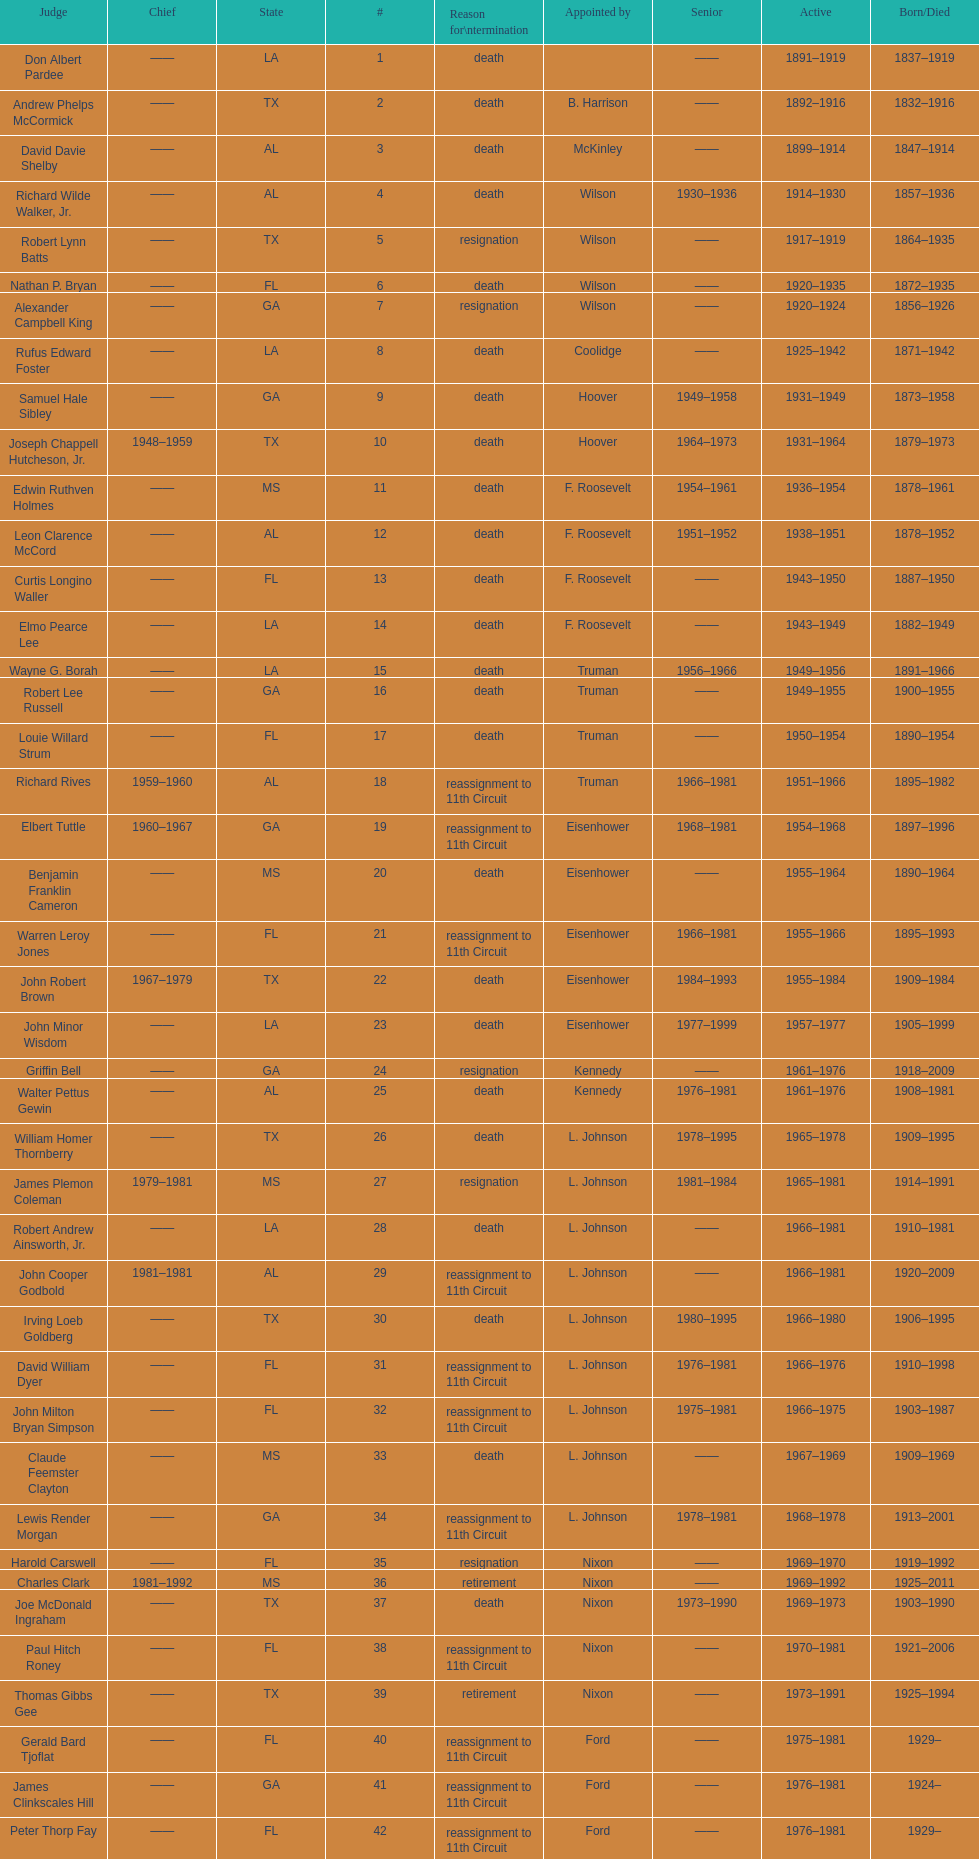Can you parse all the data within this table? {'header': ['Judge', 'Chief', 'State', '#', 'Reason for\\ntermination', 'Appointed by', 'Senior', 'Active', 'Born/Died'], 'rows': [['Don Albert Pardee', '——', 'LA', '1', 'death', '', '——', '1891–1919', '1837–1919'], ['Andrew Phelps McCormick', '——', 'TX', '2', 'death', 'B. Harrison', '——', '1892–1916', '1832–1916'], ['David Davie Shelby', '——', 'AL', '3', 'death', 'McKinley', '——', '1899–1914', '1847–1914'], ['Richard Wilde Walker, Jr.', '——', 'AL', '4', 'death', 'Wilson', '1930–1936', '1914–1930', '1857–1936'], ['Robert Lynn Batts', '——', 'TX', '5', 'resignation', 'Wilson', '——', '1917–1919', '1864–1935'], ['Nathan P. Bryan', '——', 'FL', '6', 'death', 'Wilson', '——', '1920–1935', '1872–1935'], ['Alexander Campbell King', '——', 'GA', '7', 'resignation', 'Wilson', '——', '1920–1924', '1856–1926'], ['Rufus Edward Foster', '——', 'LA', '8', 'death', 'Coolidge', '——', '1925–1942', '1871–1942'], ['Samuel Hale Sibley', '——', 'GA', '9', 'death', 'Hoover', '1949–1958', '1931–1949', '1873–1958'], ['Joseph Chappell Hutcheson, Jr.', '1948–1959', 'TX', '10', 'death', 'Hoover', '1964–1973', '1931–1964', '1879–1973'], ['Edwin Ruthven Holmes', '——', 'MS', '11', 'death', 'F. Roosevelt', '1954–1961', '1936–1954', '1878–1961'], ['Leon Clarence McCord', '——', 'AL', '12', 'death', 'F. Roosevelt', '1951–1952', '1938–1951', '1878–1952'], ['Curtis Longino Waller', '——', 'FL', '13', 'death', 'F. Roosevelt', '——', '1943–1950', '1887–1950'], ['Elmo Pearce Lee', '——', 'LA', '14', 'death', 'F. Roosevelt', '——', '1943–1949', '1882–1949'], ['Wayne G. Borah', '——', 'LA', '15', 'death', 'Truman', '1956–1966', '1949–1956', '1891–1966'], ['Robert Lee Russell', '——', 'GA', '16', 'death', 'Truman', '——', '1949–1955', '1900–1955'], ['Louie Willard Strum', '——', 'FL', '17', 'death', 'Truman', '——', '1950–1954', '1890–1954'], ['Richard Rives', '1959–1960', 'AL', '18', 'reassignment to 11th Circuit', 'Truman', '1966–1981', '1951–1966', '1895–1982'], ['Elbert Tuttle', '1960–1967', 'GA', '19', 'reassignment to 11th Circuit', 'Eisenhower', '1968–1981', '1954–1968', '1897–1996'], ['Benjamin Franklin Cameron', '——', 'MS', '20', 'death', 'Eisenhower', '——', '1955–1964', '1890–1964'], ['Warren Leroy Jones', '——', 'FL', '21', 'reassignment to 11th Circuit', 'Eisenhower', '1966–1981', '1955–1966', '1895–1993'], ['John Robert Brown', '1967–1979', 'TX', '22', 'death', 'Eisenhower', '1984–1993', '1955–1984', '1909–1984'], ['John Minor Wisdom', '——', 'LA', '23', 'death', 'Eisenhower', '1977–1999', '1957–1977', '1905–1999'], ['Griffin Bell', '——', 'GA', '24', 'resignation', 'Kennedy', '——', '1961–1976', '1918–2009'], ['Walter Pettus Gewin', '——', 'AL', '25', 'death', 'Kennedy', '1976–1981', '1961–1976', '1908–1981'], ['William Homer Thornberry', '——', 'TX', '26', 'death', 'L. Johnson', '1978–1995', '1965–1978', '1909–1995'], ['James Plemon Coleman', '1979–1981', 'MS', '27', 'resignation', 'L. Johnson', '1981–1984', '1965–1981', '1914–1991'], ['Robert Andrew Ainsworth, Jr.', '——', 'LA', '28', 'death', 'L. Johnson', '——', '1966–1981', '1910–1981'], ['John Cooper Godbold', '1981–1981', 'AL', '29', 'reassignment to 11th Circuit', 'L. Johnson', '——', '1966–1981', '1920–2009'], ['Irving Loeb Goldberg', '——', 'TX', '30', 'death', 'L. Johnson', '1980–1995', '1966–1980', '1906–1995'], ['David William Dyer', '——', 'FL', '31', 'reassignment to 11th Circuit', 'L. Johnson', '1976–1981', '1966–1976', '1910–1998'], ['John Milton Bryan Simpson', '——', 'FL', '32', 'reassignment to 11th Circuit', 'L. Johnson', '1975–1981', '1966–1975', '1903–1987'], ['Claude Feemster Clayton', '——', 'MS', '33', 'death', 'L. Johnson', '——', '1967–1969', '1909–1969'], ['Lewis Render Morgan', '——', 'GA', '34', 'reassignment to 11th Circuit', 'L. Johnson', '1978–1981', '1968–1978', '1913–2001'], ['Harold Carswell', '——', 'FL', '35', 'resignation', 'Nixon', '——', '1969–1970', '1919–1992'], ['Charles Clark', '1981–1992', 'MS', '36', 'retirement', 'Nixon', '——', '1969–1992', '1925–2011'], ['Joe McDonald Ingraham', '——', 'TX', '37', 'death', 'Nixon', '1973–1990', '1969–1973', '1903–1990'], ['Paul Hitch Roney', '——', 'FL', '38', 'reassignment to 11th Circuit', 'Nixon', '——', '1970–1981', '1921–2006'], ['Thomas Gibbs Gee', '——', 'TX', '39', 'retirement', 'Nixon', '——', '1973–1991', '1925–1994'], ['Gerald Bard Tjoflat', '——', 'FL', '40', 'reassignment to 11th Circuit', 'Ford', '——', '1975–1981', '1929–'], ['James Clinkscales Hill', '——', 'GA', '41', 'reassignment to 11th Circuit', 'Ford', '——', '1976–1981', '1924–'], ['Peter Thorp Fay', '——', 'FL', '42', 'reassignment to 11th Circuit', 'Ford', '——', '1976–1981', '1929–'], ['Alvin Benjamin Rubin', '——', 'LA', '43', 'death', 'Carter', '1989–1991', '1977–1989', '1920–1991'], ['Robert Smith Vance', '——', 'AL', '44', 'reassignment to 11th Circuit', 'Carter', '——', '1977–1981', '1931–1989'], ['Phyllis A. Kravitch', '——', 'GA', '45', 'reassignment to 11th Circuit', 'Carter', '——', '1979–1981', '1920–'], ['Frank Minis Johnson', '——', 'AL', '46', 'reassignment to 11th Circuit', 'Carter', '——', '1979–1981', '1918–1999'], ['R. Lanier Anderson III', '——', 'GA', '47', 'reassignment to 11th Circuit', 'Carter', '——', '1979–1981', '1936–'], ['Reynaldo Guerra Garza', '——', 'TX', '48', 'death', 'Carter', '1982–2004', '1979–1982', '1915–2004'], ['Joseph Woodrow Hatchett', '——', 'FL', '49', 'reassignment to 11th Circuit', 'Carter', '——', '1979–1981', '1932–'], ['Albert John Henderson', '——', 'GA', '50', 'reassignment to 11th Circuit', 'Carter', '——', '1979–1981', '1920–1999'], ['Henry Anthony Politz', '1992–1999', 'LA', '52', 'death', 'Carter', '1999–2002', '1979–1999', '1932–2002'], ['Samuel D. Johnson, Jr.', '——', 'TX', '54', 'death', 'Carter', '1991–2002', '1979–1991', '1920–2002'], ['Albert Tate, Jr.', '——', 'LA', '55', 'death', 'Carter', '——', '1979–1986', '1920–1986'], ['Thomas Alonzo Clark', '——', 'GA', '56', 'reassignment to 11th Circuit', 'Carter', '——', '1979–1981', '1920–2005'], ['Jerre Stockton Williams', '——', 'TX', '57', 'death', 'Carter', '1990–1993', '1980–1990', '1916–1993'], ['William Lockhart Garwood', '——', 'TX', '58', 'death', 'Reagan', '1997–2011', '1981–1997', '1931–2011'], ['Robert Madden Hill', '——', 'TX', '62', 'death', 'Reagan', '——', '1984–1987', '1928–1987'], ['John Malcolm Duhé, Jr.', '——', 'LA', '65', 'retirement', 'Reagan', '1999–2011', '1988–1999', '1933-'], ['Robert Manley Parker', '——', 'TX', '72', 'retirement', 'Clinton', '——', '1994–2002', '1937–'], ['Charles W. Pickering', '——', 'MS', '76', 'retirement', 'G.W. Bush', '——', '2004–2004', '1937–']]} Which judge was last appointed by president truman? Richard Rives. 